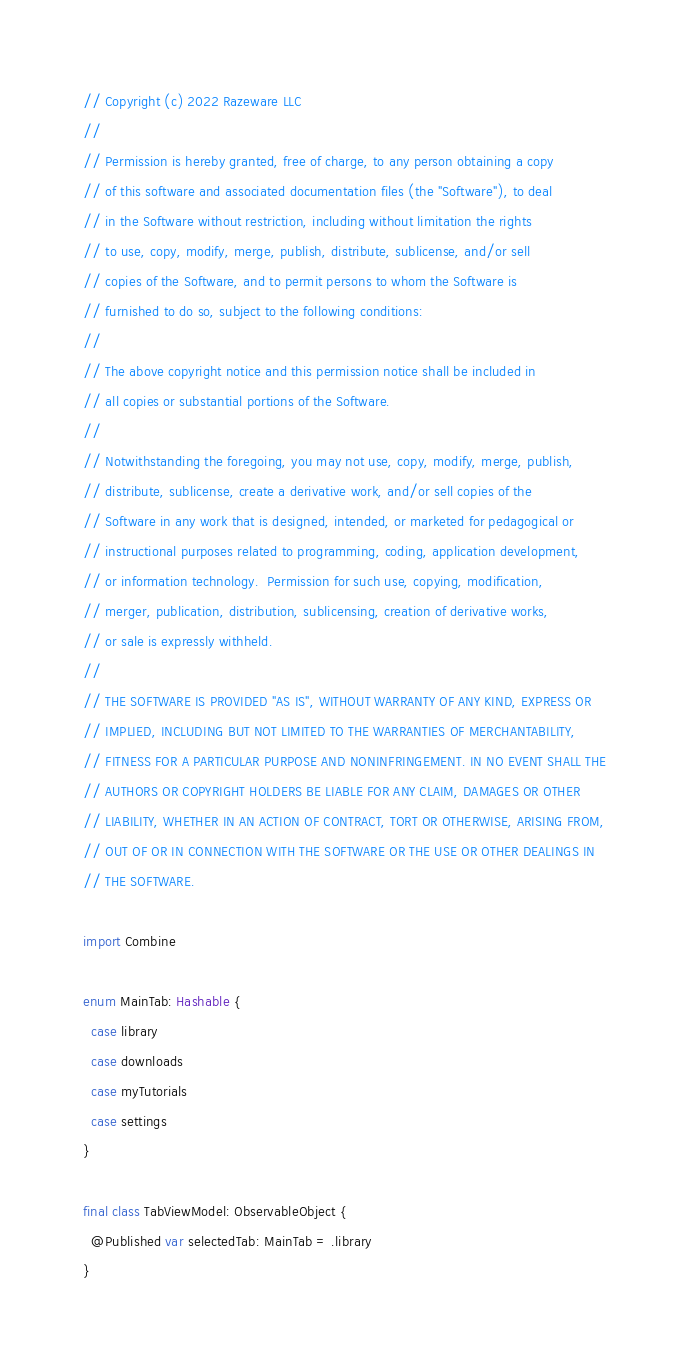Convert code to text. <code><loc_0><loc_0><loc_500><loc_500><_Swift_>// Copyright (c) 2022 Razeware LLC
//
// Permission is hereby granted, free of charge, to any person obtaining a copy
// of this software and associated documentation files (the "Software"), to deal
// in the Software without restriction, including without limitation the rights
// to use, copy, modify, merge, publish, distribute, sublicense, and/or sell
// copies of the Software, and to permit persons to whom the Software is
// furnished to do so, subject to the following conditions:
//
// The above copyright notice and this permission notice shall be included in
// all copies or substantial portions of the Software.
//
// Notwithstanding the foregoing, you may not use, copy, modify, merge, publish,
// distribute, sublicense, create a derivative work, and/or sell copies of the
// Software in any work that is designed, intended, or marketed for pedagogical or
// instructional purposes related to programming, coding, application development,
// or information technology.  Permission for such use, copying, modification,
// merger, publication, distribution, sublicensing, creation of derivative works,
// or sale is expressly withheld.
//
// THE SOFTWARE IS PROVIDED "AS IS", WITHOUT WARRANTY OF ANY KIND, EXPRESS OR
// IMPLIED, INCLUDING BUT NOT LIMITED TO THE WARRANTIES OF MERCHANTABILITY,
// FITNESS FOR A PARTICULAR PURPOSE AND NONINFRINGEMENT. IN NO EVENT SHALL THE
// AUTHORS OR COPYRIGHT HOLDERS BE LIABLE FOR ANY CLAIM, DAMAGES OR OTHER
// LIABILITY, WHETHER IN AN ACTION OF CONTRACT, TORT OR OTHERWISE, ARISING FROM,
// OUT OF OR IN CONNECTION WITH THE SOFTWARE OR THE USE OR OTHER DEALINGS IN
// THE SOFTWARE.

import Combine

enum MainTab: Hashable {
  case library
  case downloads
  case myTutorials
  case settings
}

final class TabViewModel: ObservableObject {
  @Published var selectedTab: MainTab = .library
}
</code> 